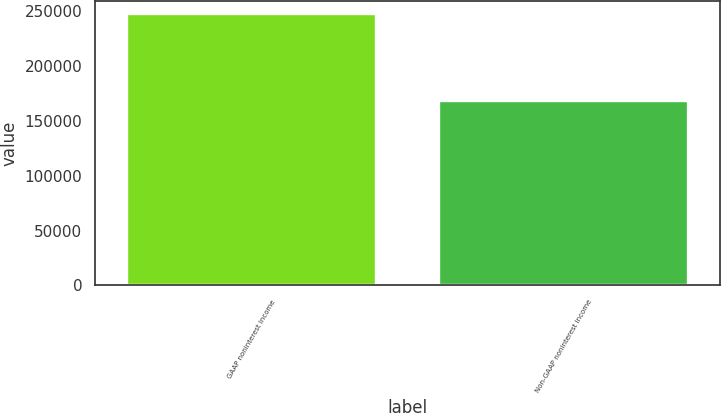<chart> <loc_0><loc_0><loc_500><loc_500><bar_chart><fcel>GAAP noninterest income<fcel>Non-GAAP noninterest income<nl><fcel>247530<fcel>168645<nl></chart> 